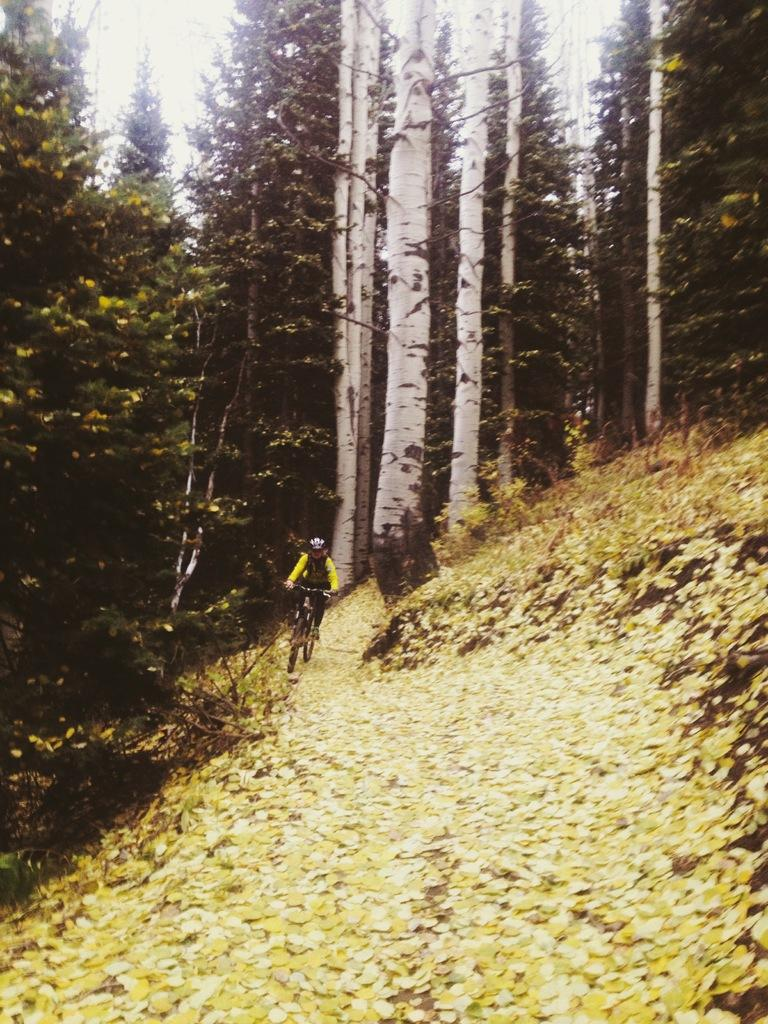What is the main subject of the image? There is a person riding a bicycle in the image. What is the color of the ground in the image? The ground is yellow in color. What can be seen in the background of the image? There are trees visible in the background of the image. What type of branch is the person holding while riding the bicycle in the image? There is no branch present in the image; the person is riding a bicycle without holding any branches. Who is the creator of the trees visible in the background of the image? The creator of the trees is not mentioned in the image, as they are natural elements that grow over time. 